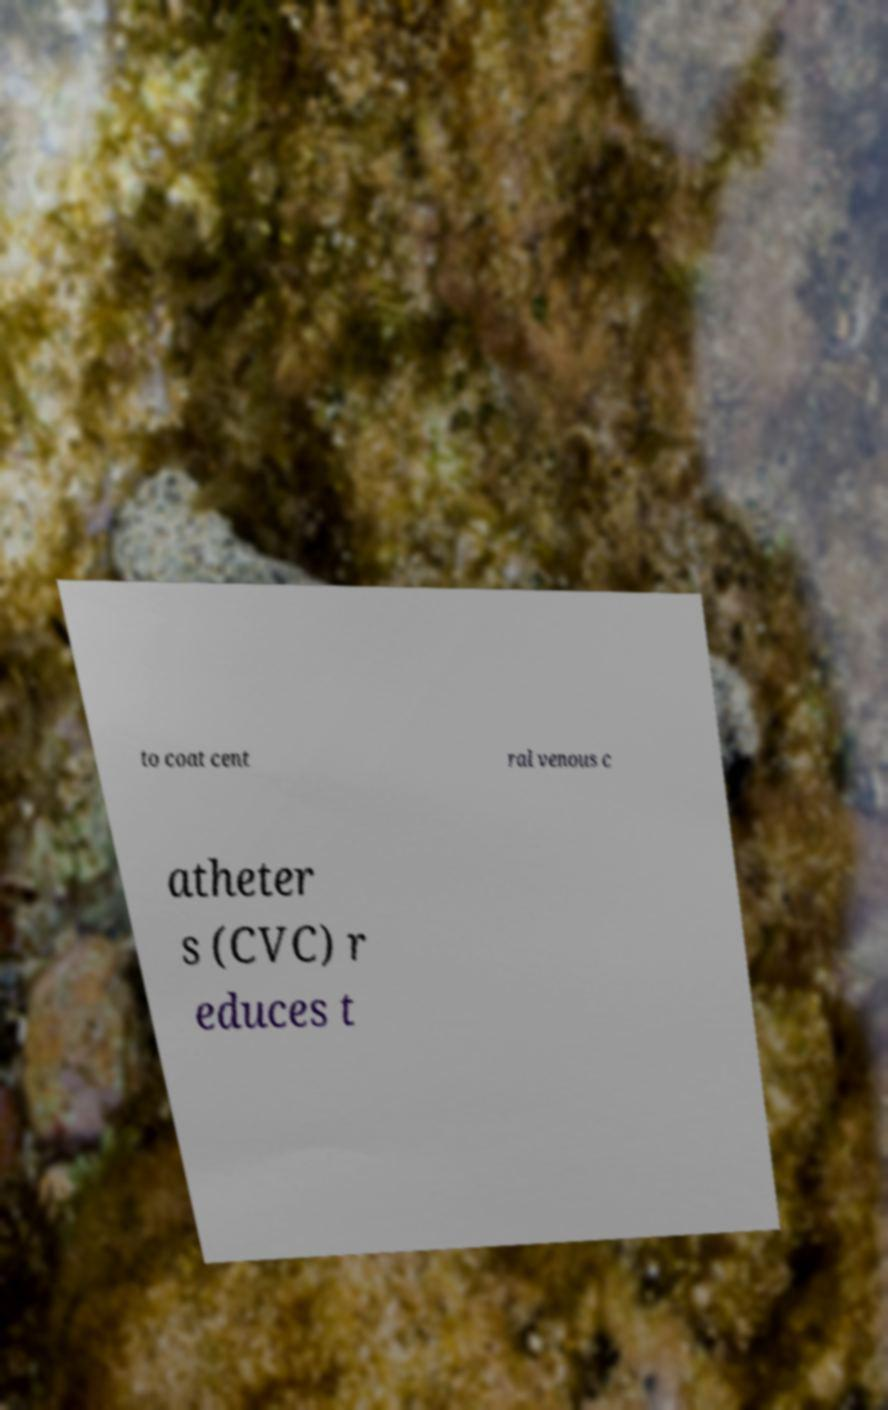Can you accurately transcribe the text from the provided image for me? to coat cent ral venous c atheter s (CVC) r educes t 